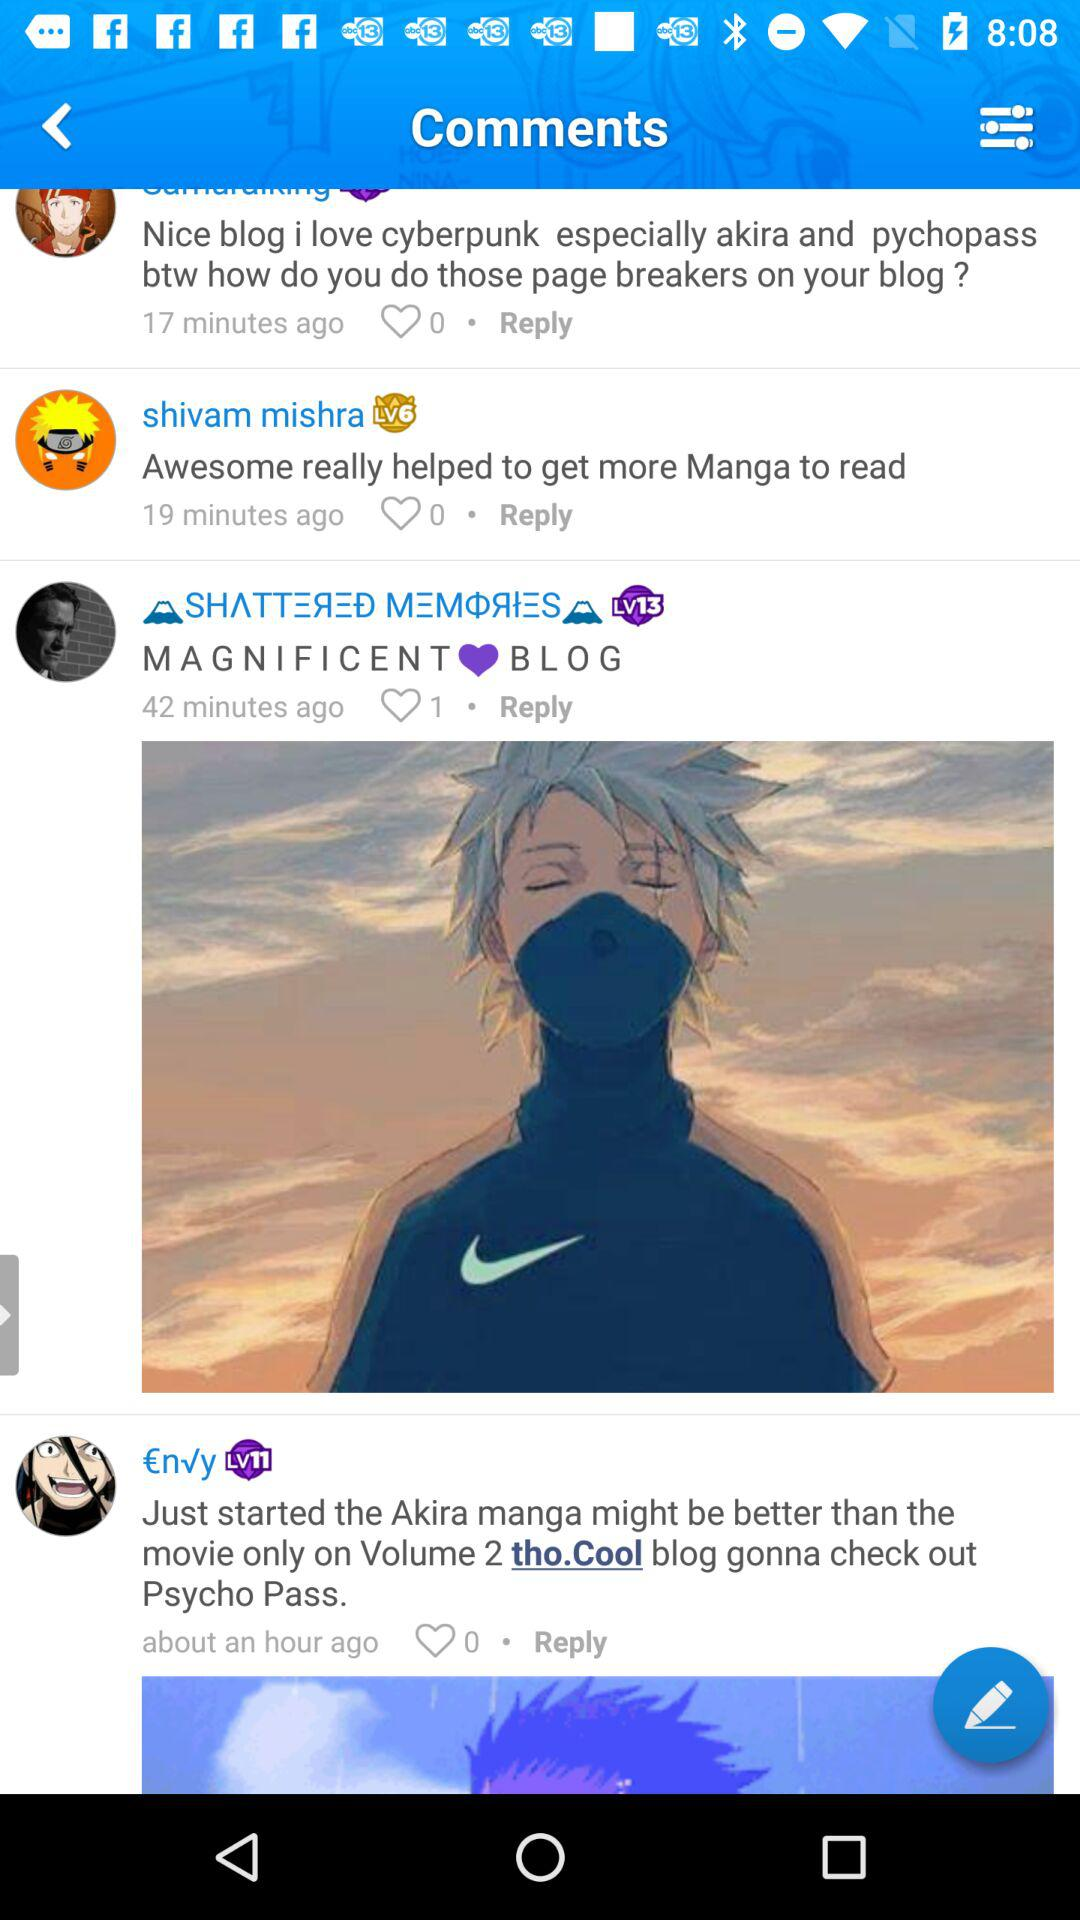How many likes are there of "MAGNIFICENT BLOG"? There is 1 like of "MAGNIFICENT BLOG". 